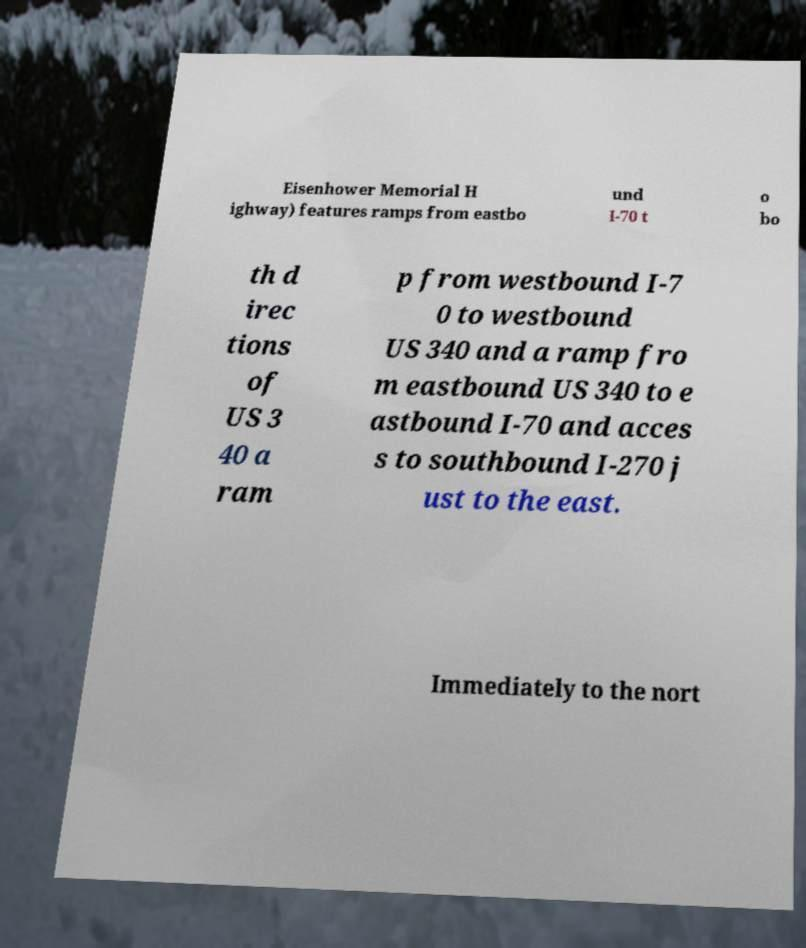For documentation purposes, I need the text within this image transcribed. Could you provide that? Eisenhower Memorial H ighway) features ramps from eastbo und I-70 t o bo th d irec tions of US 3 40 a ram p from westbound I-7 0 to westbound US 340 and a ramp fro m eastbound US 340 to e astbound I-70 and acces s to southbound I-270 j ust to the east. Immediately to the nort 